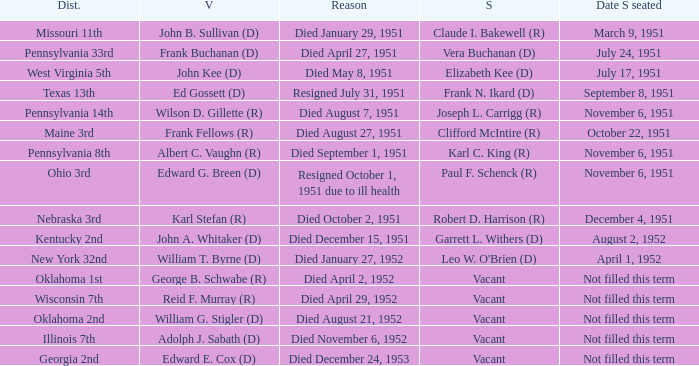How many vacators were in the Pennsylvania 33rd district? 1.0. I'm looking to parse the entire table for insights. Could you assist me with that? {'header': ['Dist.', 'V', 'Reason', 'S', 'Date S seated'], 'rows': [['Missouri 11th', 'John B. Sullivan (D)', 'Died January 29, 1951', 'Claude I. Bakewell (R)', 'March 9, 1951'], ['Pennsylvania 33rd', 'Frank Buchanan (D)', 'Died April 27, 1951', 'Vera Buchanan (D)', 'July 24, 1951'], ['West Virginia 5th', 'John Kee (D)', 'Died May 8, 1951', 'Elizabeth Kee (D)', 'July 17, 1951'], ['Texas 13th', 'Ed Gossett (D)', 'Resigned July 31, 1951', 'Frank N. Ikard (D)', 'September 8, 1951'], ['Pennsylvania 14th', 'Wilson D. Gillette (R)', 'Died August 7, 1951', 'Joseph L. Carrigg (R)', 'November 6, 1951'], ['Maine 3rd', 'Frank Fellows (R)', 'Died August 27, 1951', 'Clifford McIntire (R)', 'October 22, 1951'], ['Pennsylvania 8th', 'Albert C. Vaughn (R)', 'Died September 1, 1951', 'Karl C. King (R)', 'November 6, 1951'], ['Ohio 3rd', 'Edward G. Breen (D)', 'Resigned October 1, 1951 due to ill health', 'Paul F. Schenck (R)', 'November 6, 1951'], ['Nebraska 3rd', 'Karl Stefan (R)', 'Died October 2, 1951', 'Robert D. Harrison (R)', 'December 4, 1951'], ['Kentucky 2nd', 'John A. Whitaker (D)', 'Died December 15, 1951', 'Garrett L. Withers (D)', 'August 2, 1952'], ['New York 32nd', 'William T. Byrne (D)', 'Died January 27, 1952', "Leo W. O'Brien (D)", 'April 1, 1952'], ['Oklahoma 1st', 'George B. Schwabe (R)', 'Died April 2, 1952', 'Vacant', 'Not filled this term'], ['Wisconsin 7th', 'Reid F. Murray (R)', 'Died April 29, 1952', 'Vacant', 'Not filled this term'], ['Oklahoma 2nd', 'William G. Stigler (D)', 'Died August 21, 1952', 'Vacant', 'Not filled this term'], ['Illinois 7th', 'Adolph J. Sabath (D)', 'Died November 6, 1952', 'Vacant', 'Not filled this term'], ['Georgia 2nd', 'Edward E. Cox (D)', 'Died December 24, 1953', 'Vacant', 'Not filled this term']]} 